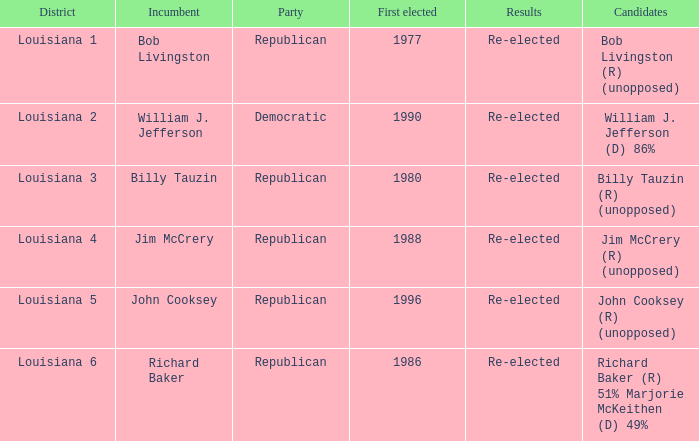What is the political affiliation of william j. jefferson? Democratic. 